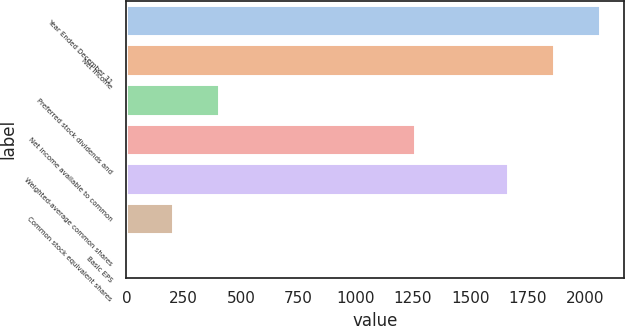<chart> <loc_0><loc_0><loc_500><loc_500><bar_chart><fcel>Year Ended December 31<fcel>Net income<fcel>Preferred stock dividends and<fcel>Net income available to common<fcel>Weighted-average common shares<fcel>Common stock equivalent shares<fcel>Basic EPS<nl><fcel>2066.2<fcel>1864.9<fcel>403.56<fcel>1261<fcel>1663.6<fcel>202.26<fcel>0.96<nl></chart> 